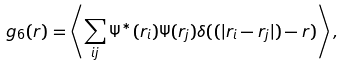<formula> <loc_0><loc_0><loc_500><loc_500>g _ { 6 } ( r ) = \left < \sum _ { i j } \Psi ^ { * } ( r _ { i } ) \Psi ( r _ { j } ) \delta ( ( | r _ { i } - r _ { j } | ) - r ) \right > ,</formula> 